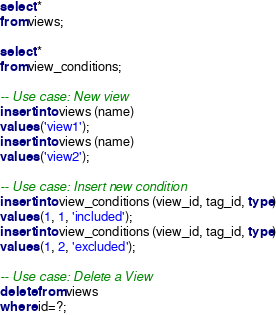Convert code to text. <code><loc_0><loc_0><loc_500><loc_500><_SQL_>select *
from views;

select *
from view_conditions;

-- Use case: New view
insert into views (name)
values ('view1');
insert into views (name)
values ('view2');

-- Use case: Insert new condition
insert into view_conditions (view_id, tag_id, type)
values (1, 1, 'included');
insert into view_conditions (view_id, tag_id, type)
values (1, 2, 'excluded');

-- Use case: Delete a View
delete from views
where id=?;
</code> 